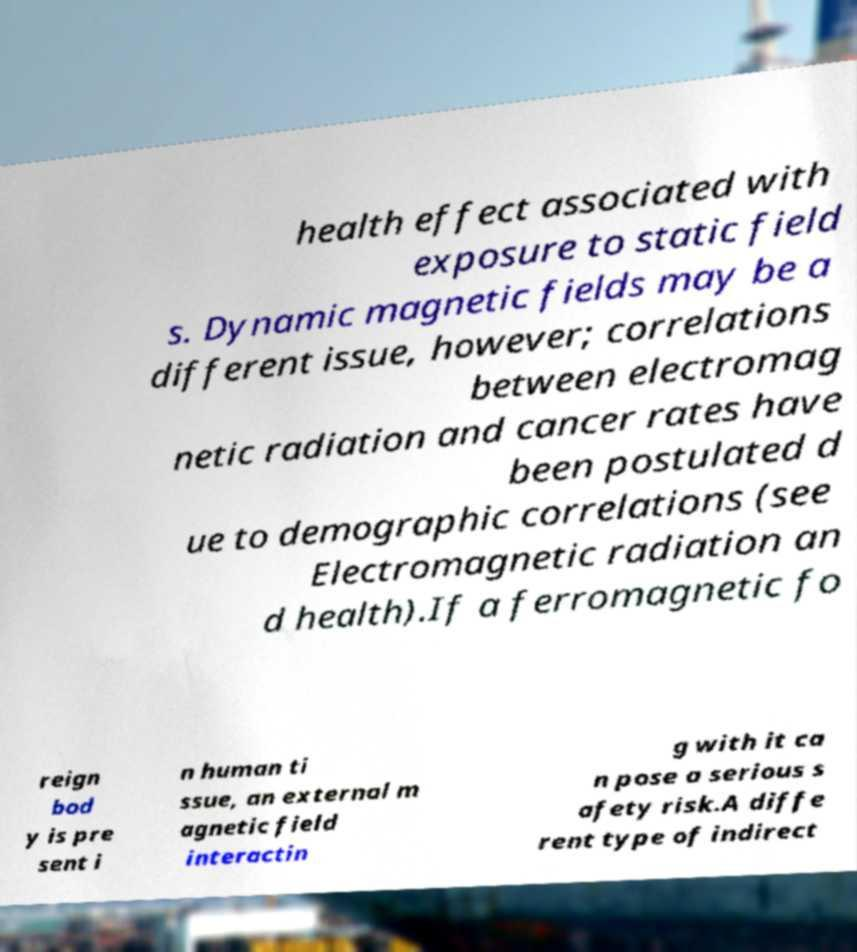There's text embedded in this image that I need extracted. Can you transcribe it verbatim? health effect associated with exposure to static field s. Dynamic magnetic fields may be a different issue, however; correlations between electromag netic radiation and cancer rates have been postulated d ue to demographic correlations (see Electromagnetic radiation an d health).If a ferromagnetic fo reign bod y is pre sent i n human ti ssue, an external m agnetic field interactin g with it ca n pose a serious s afety risk.A diffe rent type of indirect 